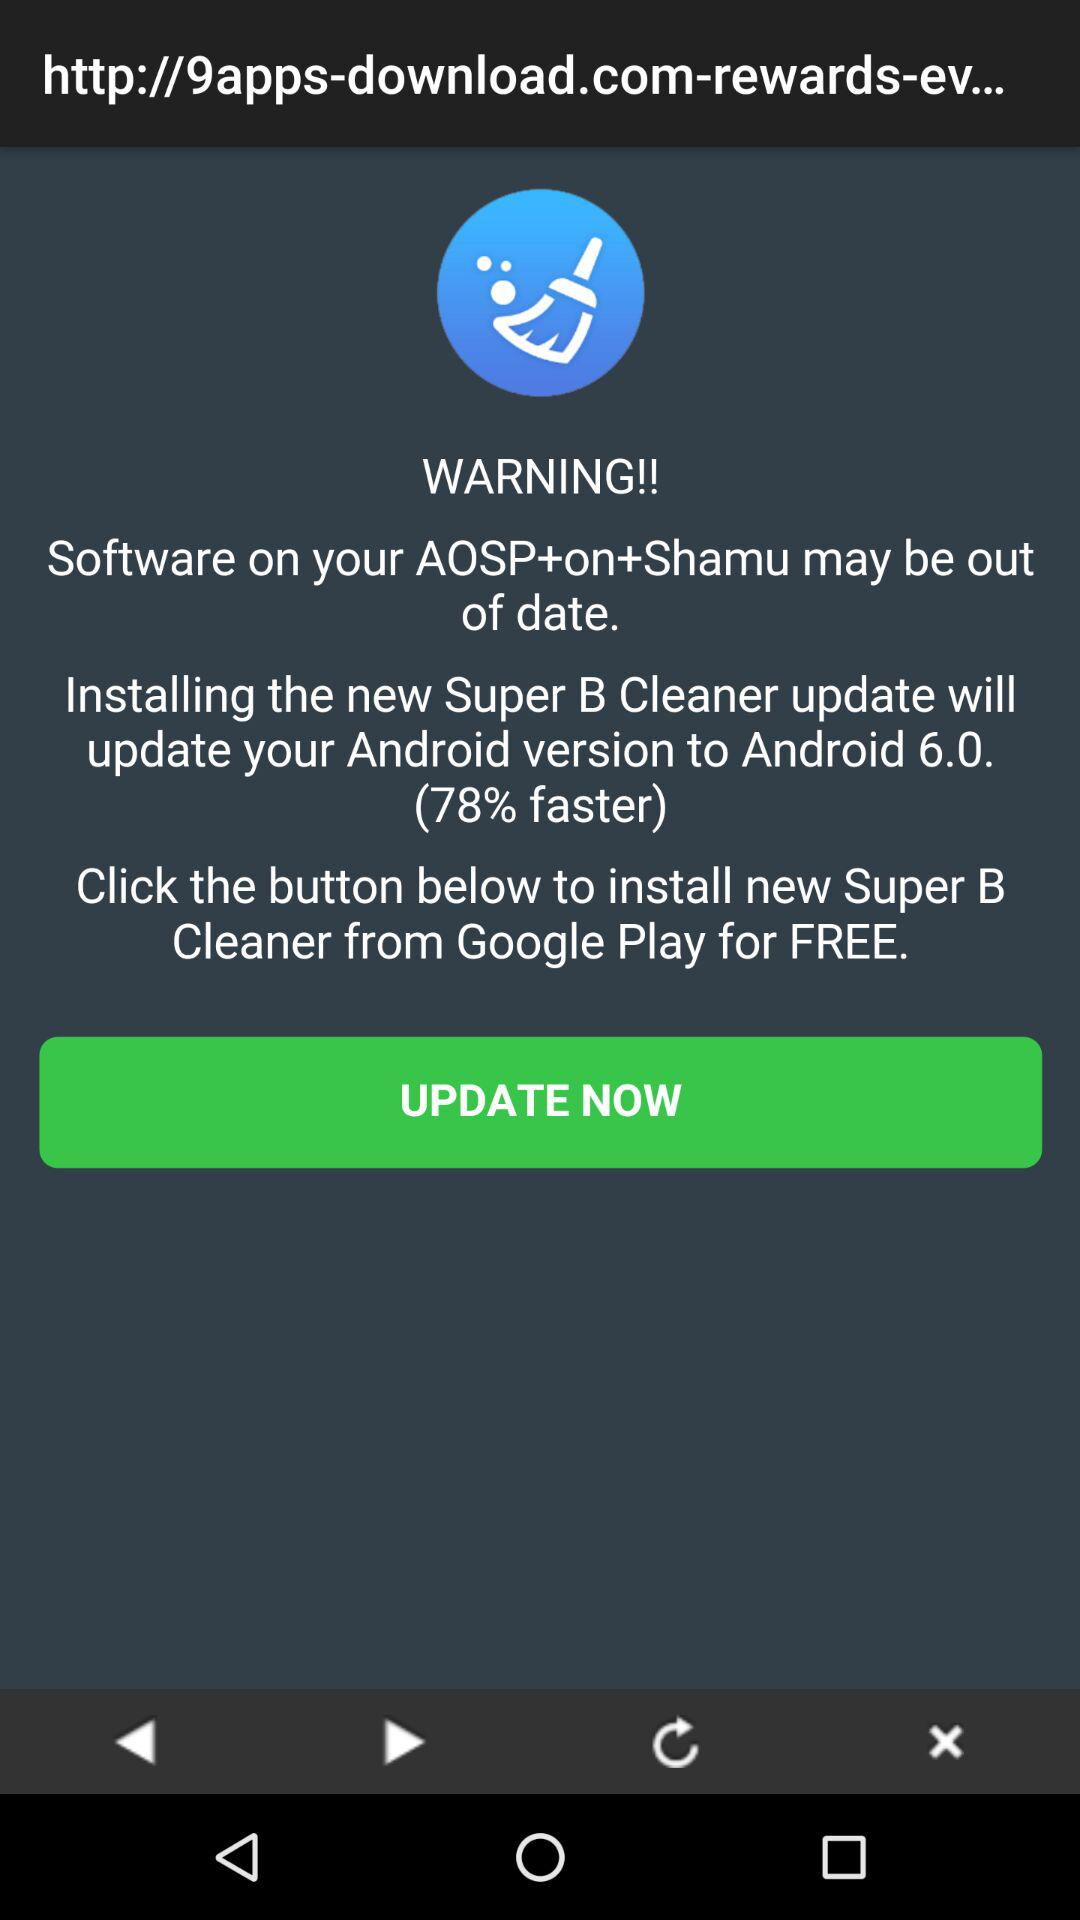How much faster is this version? This version is 78% faster. 